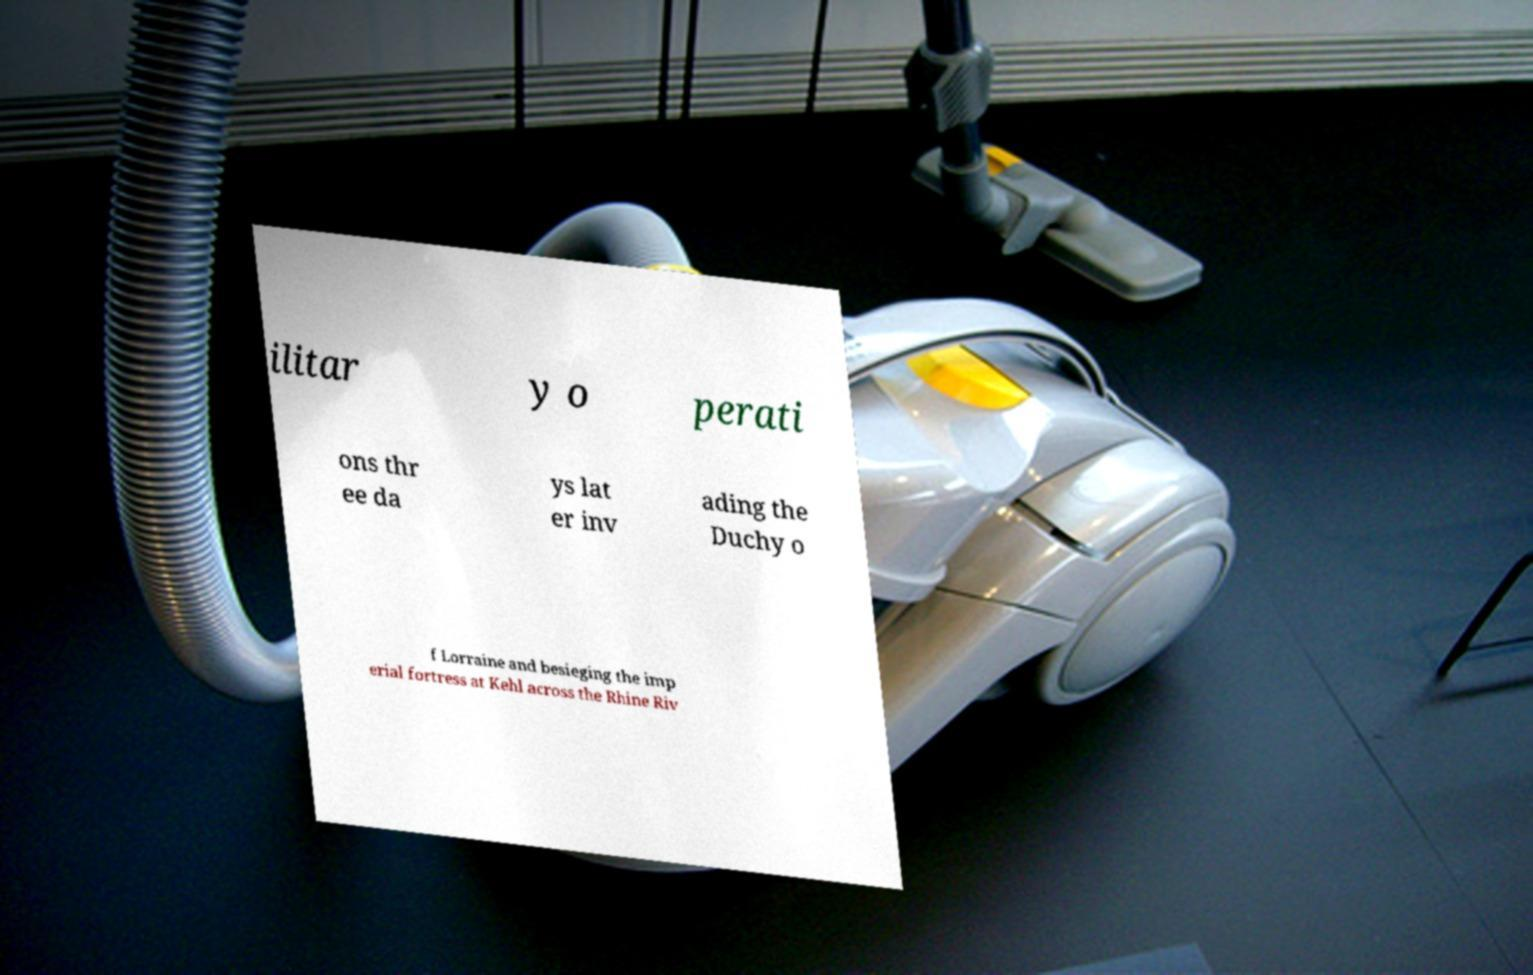Please identify and transcribe the text found in this image. ilitar y o perati ons thr ee da ys lat er inv ading the Duchy o f Lorraine and besieging the imp erial fortress at Kehl across the Rhine Riv 